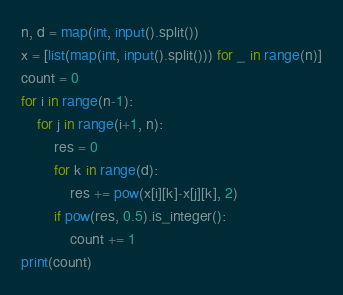<code> <loc_0><loc_0><loc_500><loc_500><_Python_>n, d = map(int, input().split())
x = [list(map(int, input().split())) for _ in range(n)]
count = 0
for i in range(n-1):
    for j in range(i+1, n):
        res = 0
        for k in range(d):
            res += pow(x[i][k]-x[j][k], 2)
        if pow(res, 0.5).is_integer():
            count += 1
print(count)</code> 